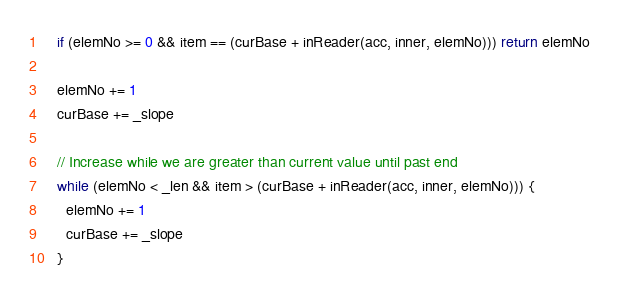<code> <loc_0><loc_0><loc_500><loc_500><_Scala_>
    if (elemNo >= 0 && item == (curBase + inReader(acc, inner, elemNo))) return elemNo

    elemNo += 1
    curBase += _slope

    // Increase while we are greater than current value until past end
    while (elemNo < _len && item > (curBase + inReader(acc, inner, elemNo))) {
      elemNo += 1
      curBase += _slope
    }
</code> 